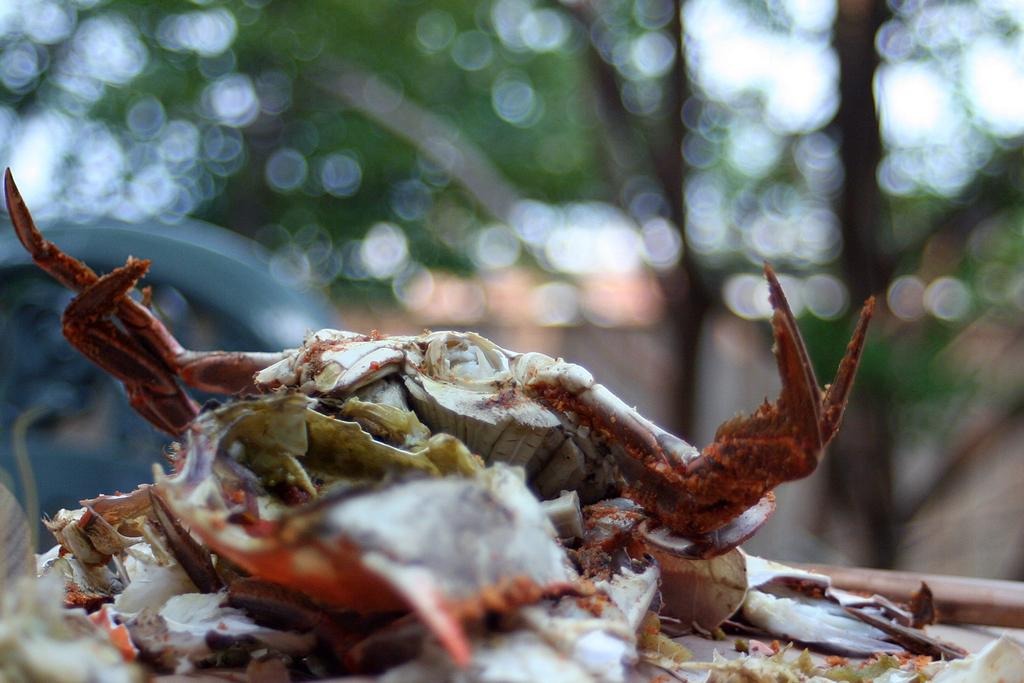What is the main subject in the center of the image? There is a crab in the center of the image. What can be seen in the background of the image? There are trees and a vehicle in the background of the image. What type of spark can be seen coming from the crab in the image? There is no spark present in the image; it features a crab and background elements. 